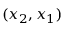<formula> <loc_0><loc_0><loc_500><loc_500>( x _ { 2 } , x _ { 1 } )</formula> 